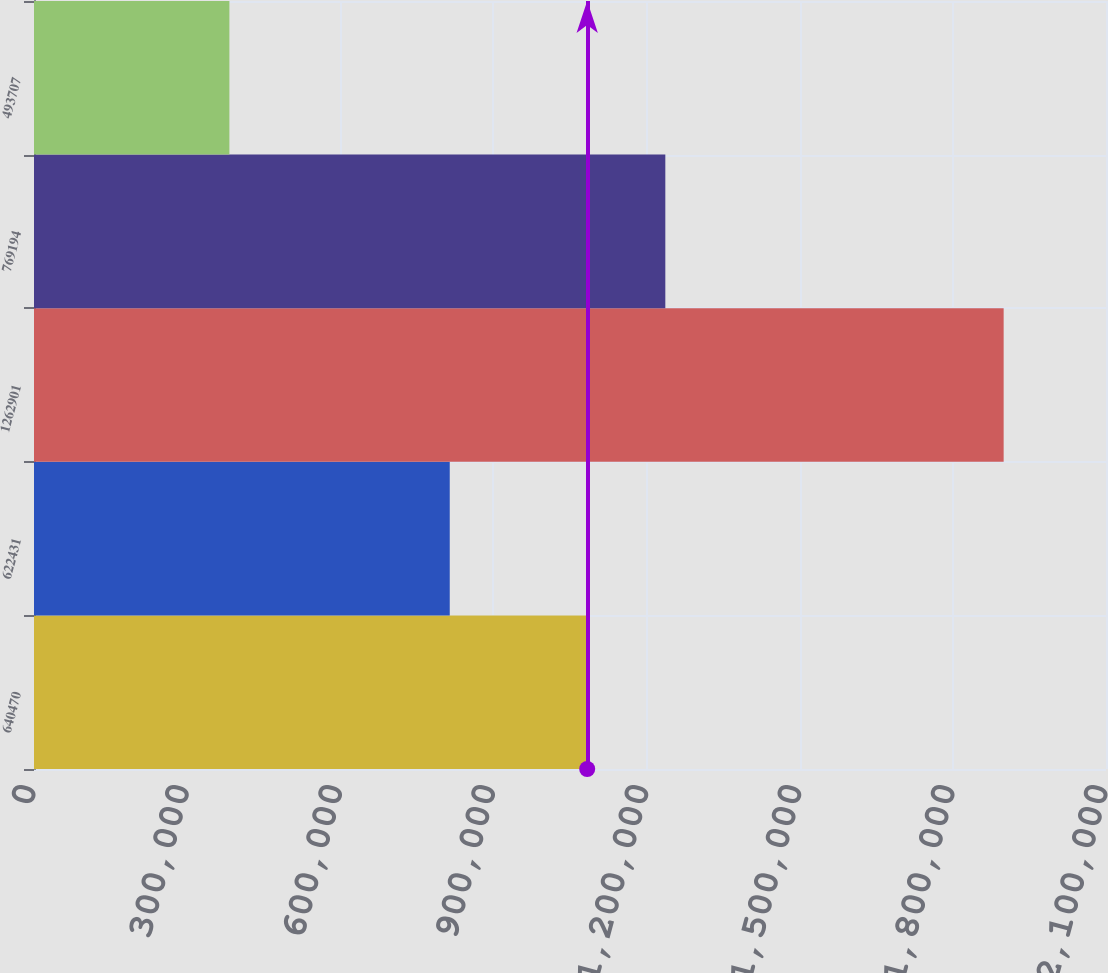<chart> <loc_0><loc_0><loc_500><loc_500><bar_chart><fcel>640470<fcel>622431<fcel>1262901<fcel>769194<fcel>493707<nl><fcel>1.08506e+06<fcel>814431<fcel>1.8995e+06<fcel>1.23674e+06<fcel>382774<nl></chart> 